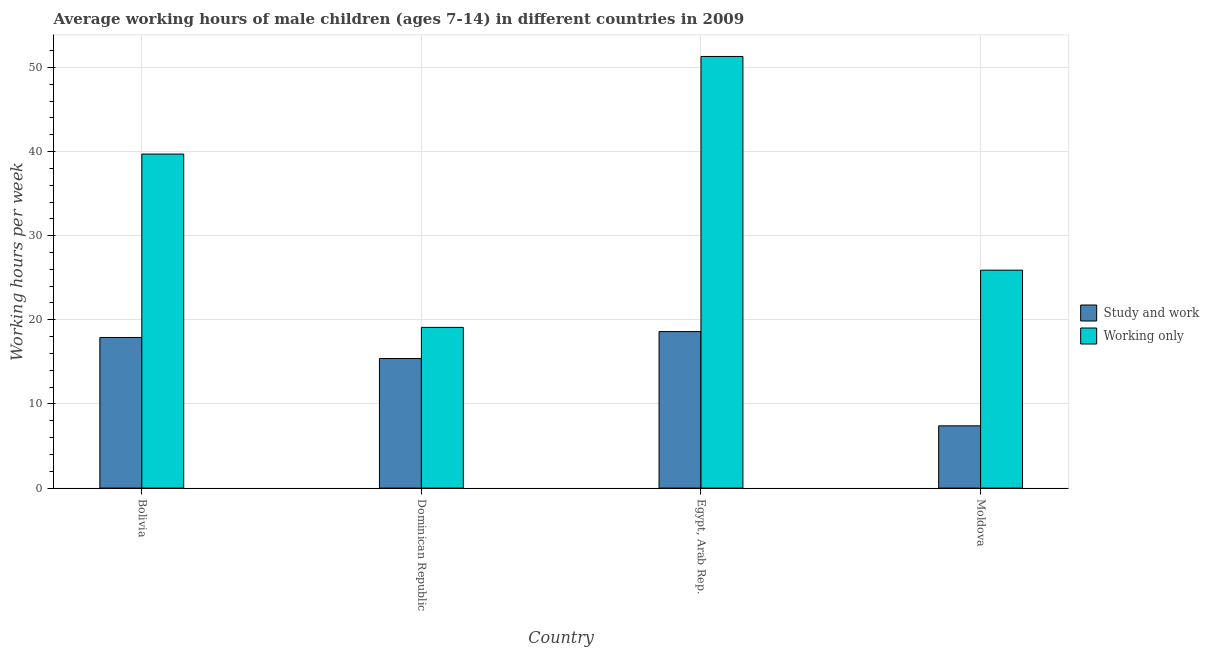Are the number of bars per tick equal to the number of legend labels?
Offer a very short reply. Yes. Are the number of bars on each tick of the X-axis equal?
Provide a short and direct response. Yes. How many bars are there on the 1st tick from the right?
Your response must be concise. 2. In which country was the average working hour of children involved in study and work maximum?
Your answer should be compact. Egypt, Arab Rep. In which country was the average working hour of children involved in only work minimum?
Provide a short and direct response. Dominican Republic. What is the total average working hour of children involved in study and work in the graph?
Your answer should be compact. 59.3. What is the difference between the average working hour of children involved in only work in Moldova and the average working hour of children involved in study and work in Egypt, Arab Rep.?
Ensure brevity in your answer.  7.3. What is the average average working hour of children involved in only work per country?
Offer a terse response. 34. What is the difference between the average working hour of children involved in study and work and average working hour of children involved in only work in Egypt, Arab Rep.?
Ensure brevity in your answer.  -32.7. What is the ratio of the average working hour of children involved in study and work in Bolivia to that in Moldova?
Give a very brief answer. 2.42. Is the difference between the average working hour of children involved in study and work in Dominican Republic and Moldova greater than the difference between the average working hour of children involved in only work in Dominican Republic and Moldova?
Make the answer very short. Yes. What is the difference between the highest and the second highest average working hour of children involved in only work?
Provide a succinct answer. 11.6. What is the difference between the highest and the lowest average working hour of children involved in study and work?
Provide a succinct answer. 11.2. In how many countries, is the average working hour of children involved in only work greater than the average average working hour of children involved in only work taken over all countries?
Give a very brief answer. 2. What does the 2nd bar from the left in Dominican Republic represents?
Your answer should be compact. Working only. What does the 2nd bar from the right in Bolivia represents?
Your response must be concise. Study and work. How many countries are there in the graph?
Offer a very short reply. 4. Are the values on the major ticks of Y-axis written in scientific E-notation?
Keep it short and to the point. No. How many legend labels are there?
Offer a terse response. 2. What is the title of the graph?
Your answer should be compact. Average working hours of male children (ages 7-14) in different countries in 2009. What is the label or title of the Y-axis?
Provide a succinct answer. Working hours per week. What is the Working hours per week in Working only in Bolivia?
Give a very brief answer. 39.7. What is the Working hours per week in Study and work in Dominican Republic?
Give a very brief answer. 15.4. What is the Working hours per week of Working only in Egypt, Arab Rep.?
Ensure brevity in your answer.  51.3. What is the Working hours per week in Working only in Moldova?
Provide a short and direct response. 25.9. Across all countries, what is the maximum Working hours per week in Working only?
Offer a very short reply. 51.3. Across all countries, what is the minimum Working hours per week in Working only?
Offer a very short reply. 19.1. What is the total Working hours per week of Study and work in the graph?
Make the answer very short. 59.3. What is the total Working hours per week in Working only in the graph?
Your response must be concise. 136. What is the difference between the Working hours per week of Study and work in Bolivia and that in Dominican Republic?
Provide a succinct answer. 2.5. What is the difference between the Working hours per week in Working only in Bolivia and that in Dominican Republic?
Your answer should be compact. 20.6. What is the difference between the Working hours per week in Study and work in Dominican Republic and that in Egypt, Arab Rep.?
Your response must be concise. -3.2. What is the difference between the Working hours per week of Working only in Dominican Republic and that in Egypt, Arab Rep.?
Provide a succinct answer. -32.2. What is the difference between the Working hours per week of Study and work in Dominican Republic and that in Moldova?
Offer a terse response. 8. What is the difference between the Working hours per week in Working only in Egypt, Arab Rep. and that in Moldova?
Keep it short and to the point. 25.4. What is the difference between the Working hours per week in Study and work in Bolivia and the Working hours per week in Working only in Dominican Republic?
Ensure brevity in your answer.  -1.2. What is the difference between the Working hours per week of Study and work in Bolivia and the Working hours per week of Working only in Egypt, Arab Rep.?
Your response must be concise. -33.4. What is the difference between the Working hours per week in Study and work in Dominican Republic and the Working hours per week in Working only in Egypt, Arab Rep.?
Your answer should be very brief. -35.9. What is the difference between the Working hours per week of Study and work in Egypt, Arab Rep. and the Working hours per week of Working only in Moldova?
Your answer should be compact. -7.3. What is the average Working hours per week in Study and work per country?
Ensure brevity in your answer.  14.82. What is the average Working hours per week of Working only per country?
Offer a very short reply. 34. What is the difference between the Working hours per week of Study and work and Working hours per week of Working only in Bolivia?
Your response must be concise. -21.8. What is the difference between the Working hours per week of Study and work and Working hours per week of Working only in Egypt, Arab Rep.?
Provide a succinct answer. -32.7. What is the difference between the Working hours per week in Study and work and Working hours per week in Working only in Moldova?
Provide a succinct answer. -18.5. What is the ratio of the Working hours per week of Study and work in Bolivia to that in Dominican Republic?
Offer a terse response. 1.16. What is the ratio of the Working hours per week of Working only in Bolivia to that in Dominican Republic?
Make the answer very short. 2.08. What is the ratio of the Working hours per week of Study and work in Bolivia to that in Egypt, Arab Rep.?
Offer a terse response. 0.96. What is the ratio of the Working hours per week in Working only in Bolivia to that in Egypt, Arab Rep.?
Your answer should be very brief. 0.77. What is the ratio of the Working hours per week of Study and work in Bolivia to that in Moldova?
Provide a short and direct response. 2.42. What is the ratio of the Working hours per week of Working only in Bolivia to that in Moldova?
Offer a very short reply. 1.53. What is the ratio of the Working hours per week in Study and work in Dominican Republic to that in Egypt, Arab Rep.?
Keep it short and to the point. 0.83. What is the ratio of the Working hours per week in Working only in Dominican Republic to that in Egypt, Arab Rep.?
Your answer should be compact. 0.37. What is the ratio of the Working hours per week in Study and work in Dominican Republic to that in Moldova?
Your answer should be compact. 2.08. What is the ratio of the Working hours per week of Working only in Dominican Republic to that in Moldova?
Offer a terse response. 0.74. What is the ratio of the Working hours per week in Study and work in Egypt, Arab Rep. to that in Moldova?
Make the answer very short. 2.51. What is the ratio of the Working hours per week in Working only in Egypt, Arab Rep. to that in Moldova?
Your answer should be compact. 1.98. What is the difference between the highest and the second highest Working hours per week in Study and work?
Keep it short and to the point. 0.7. What is the difference between the highest and the second highest Working hours per week of Working only?
Give a very brief answer. 11.6. What is the difference between the highest and the lowest Working hours per week of Working only?
Your answer should be very brief. 32.2. 